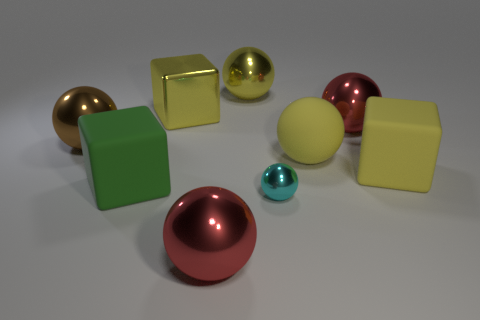Subtract all big yellow metal balls. How many balls are left? 5 Subtract all green blocks. How many blocks are left? 2 Subtract all spheres. How many objects are left? 3 Add 1 big yellow rubber spheres. How many objects exist? 10 Subtract 0 brown blocks. How many objects are left? 9 Subtract 2 cubes. How many cubes are left? 1 Subtract all gray spheres. Subtract all cyan cubes. How many spheres are left? 6 Subtract all gray balls. How many green blocks are left? 1 Subtract all brown shiny balls. Subtract all yellow cubes. How many objects are left? 6 Add 3 big red metal spheres. How many big red metal spheres are left? 5 